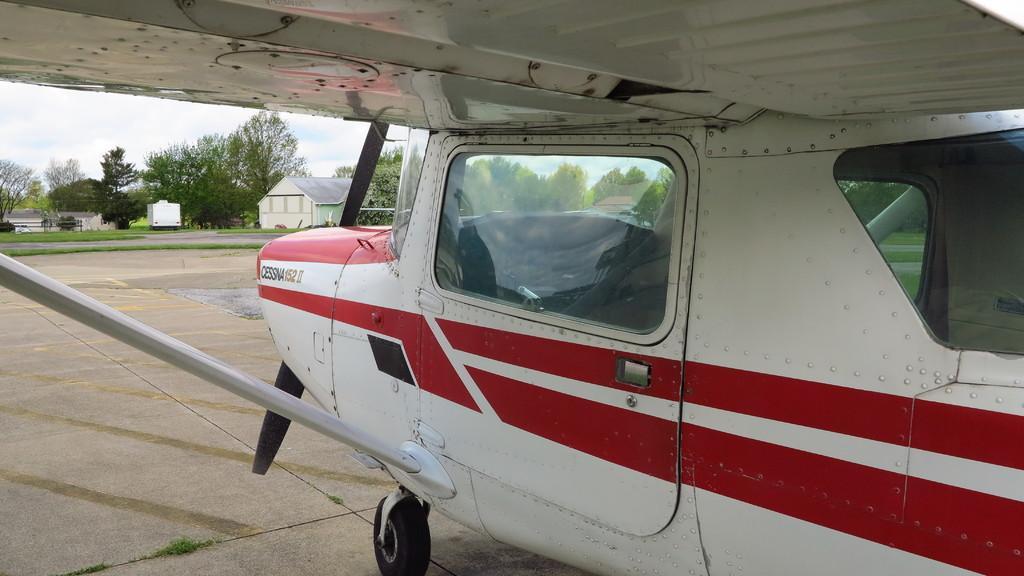Please provide a concise description of this image. In this image I can see an aircraft in the front, I can see colour of this aircraft is red and white. In the background I can see number of trees, few buildings and the sky. 